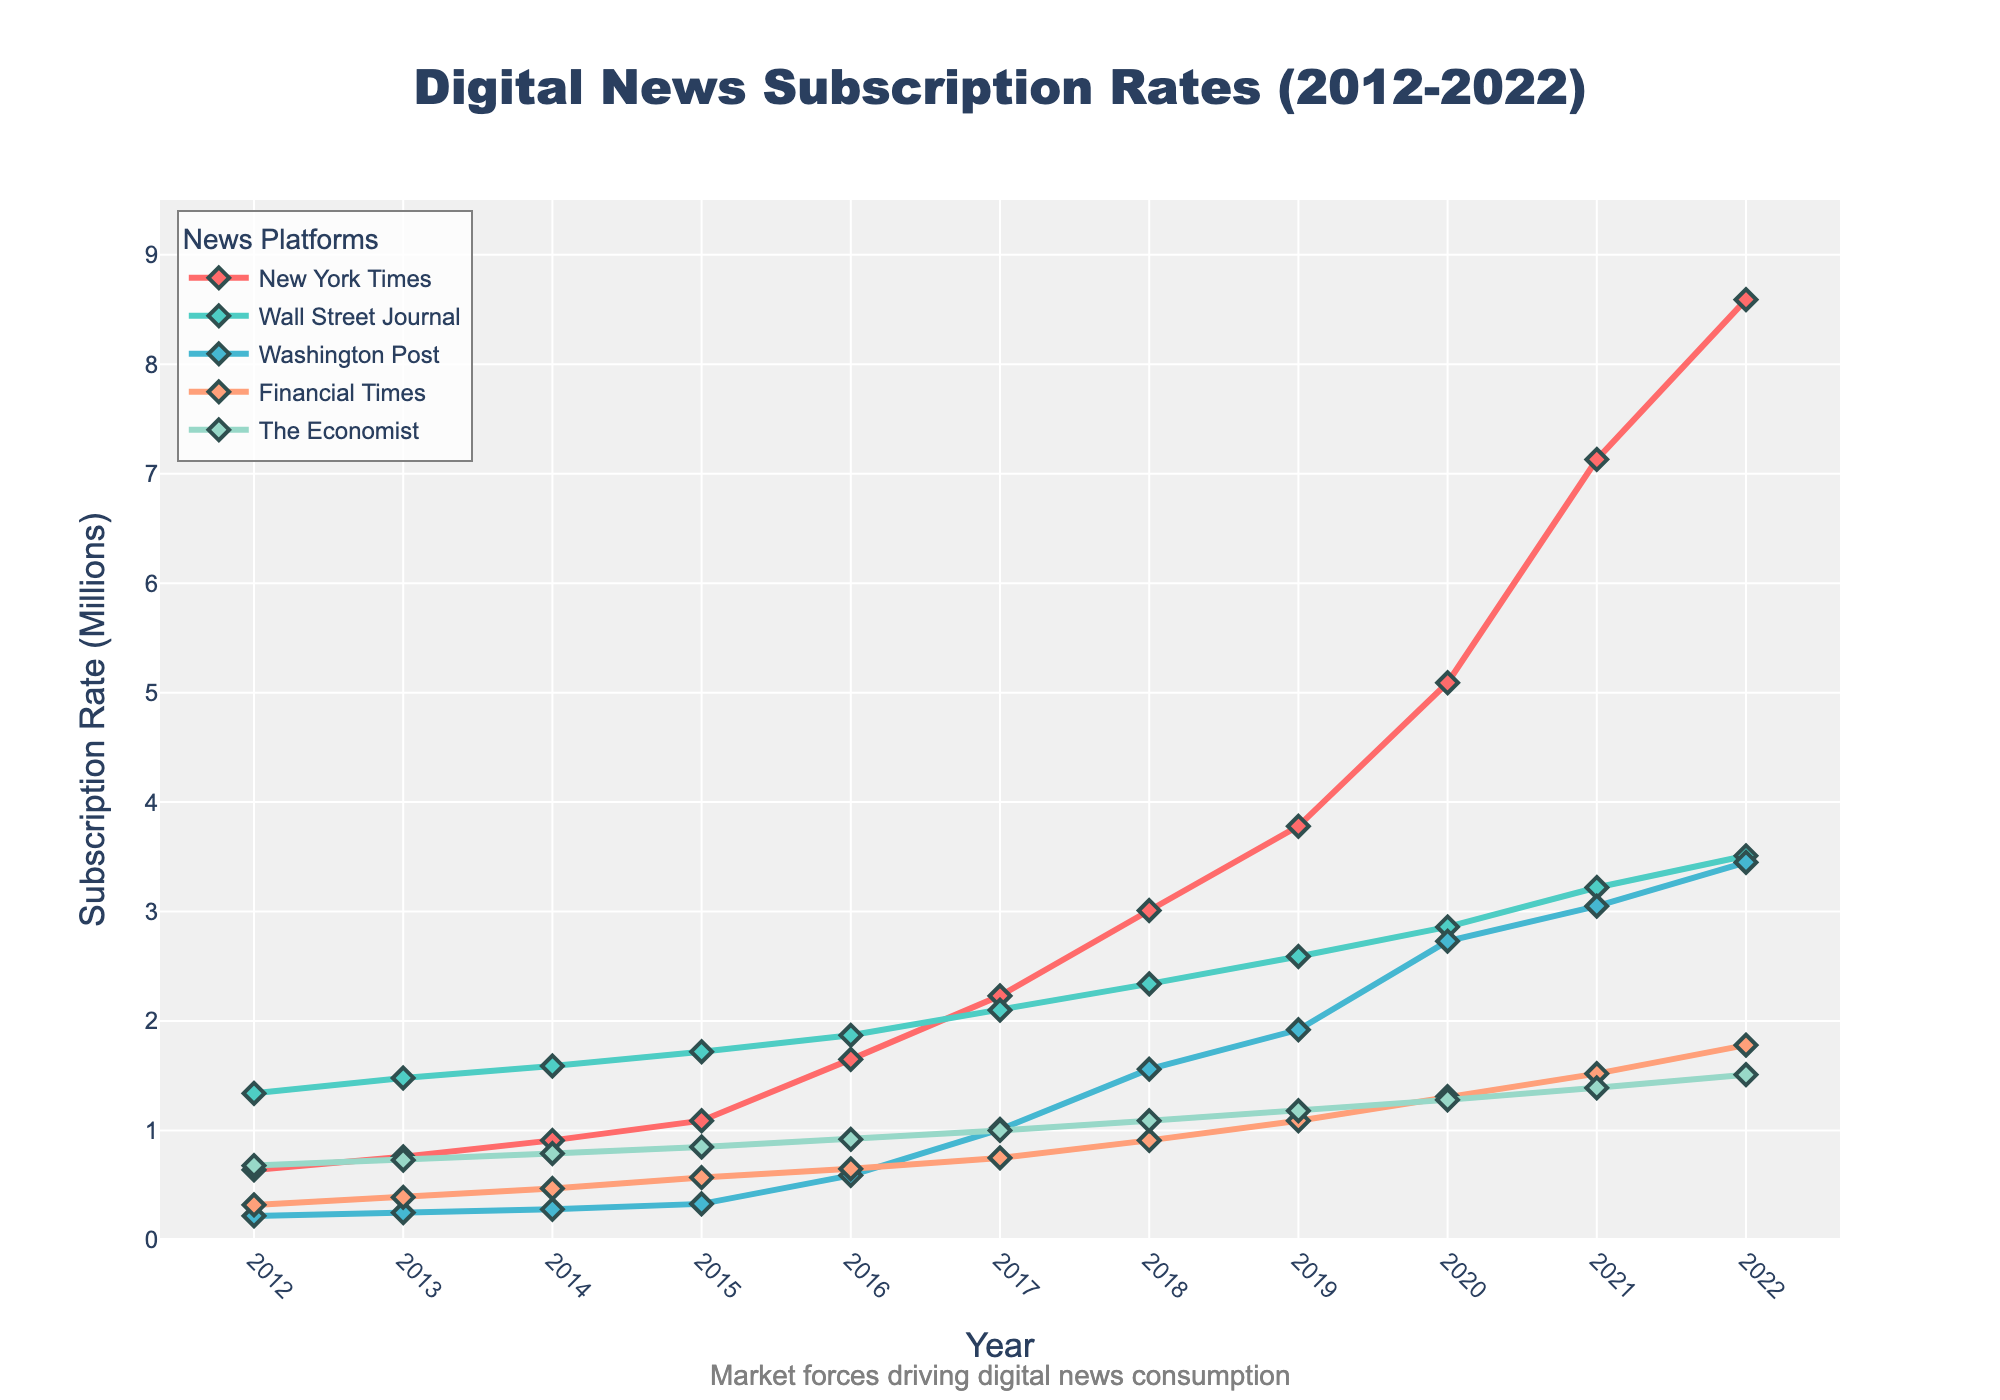What's the trend in subscription rates for the New York Times from 2012 to 2022? The subscription rate starts at 0.64 million in 2012 and consistently increases each year, reaching 8.59 million by 2022.
Answer: Steady increase Which year did the Wall Street Journal have its highest subscription rate, and what was the rate? The highest subscription rate for the Wall Street Journal is 3.51 million in 2022.
Answer: 2022, 3.51 million How does the subscription growth rate of the Washington Post between 2016 and 2018 compare to its growth between 2019 and 2022? From 2016 to 2018, the Washington Post's subscriptions grew from 0.59 million to 1.56 million (an increase of 0.97 million). Between 2019 and 2022, they grew from 1.92 million to 3.45 million (an increase of 1.53 million).
Answer: Faster growth from 2019 to 2022 What are the subscription rates of the Financial Times and The Economist in 2020, and which had higher subscriptions that year? In 2020, the Financial Times had a subscription rate of 1.31 million, while The Economist had 1.28 million.
Answer: Financial Times, 1.31 million Which platform shows the most significant increase in subscriptions from 2019 to 2020? From 2019 to 2020, the New York Times shows the most significant increase, from 3.78 million to 5.09 million (an increase of 1.31 million).
Answer: New York Times On average, how much did the subscription rate for the New York Times increase per year from 2012 to 2022? The New York Times' subscriptions increased from 0.64 million to 8.59 million over 10 years. The total increase is 8.59 - 0.64 = 7.95 million. The average annual increase is 7.95 / 10 = 0.795 million per year.
Answer: 0.795 million per year Compare the subscription rates of all platforms in 2012 and 2022. Which platform had the highest increase? In 2012, the New York Times had 0.64 million, the Wall Street Journal had 1.34 million, the Washington Post had 0.22 million, the Financial Times had 0.32 million, and The Economist had 0.68 million. In 2022, the figures are 8.59 million, 3.51 million, 3.45 million, 1.78 million, and 1.51 million, respectively. The New York Times had the highest increase, from 0.64 million to 8.59 million (an increase of 7.95 million).
Answer: New York Times Which platform had a subscription rate closest to 1 million in 2017? In 2017, the Washington Post had a subscription rate of 1.01 million, which is closest to 1 million.
Answer: Washington Post Are there any platforms where the subscription rate decreased from one year to the next? If so, identify one example. Yes, the Wall Street Journal's subscriptions decreased from 2019 to 2020, going from 2.59 million to 2.86 million.
Answer: Wall Street Journal from 2019 to 2020 By how many millions did the subscription rate of The Economist increase from 2013 to 2022? The Economist's subscription rate increased from 0.73 million in 2013 to 1.51 million in 2022. The increase is 1.51 - 0.73 = 0.78 million.
Answer: 0.78 million 